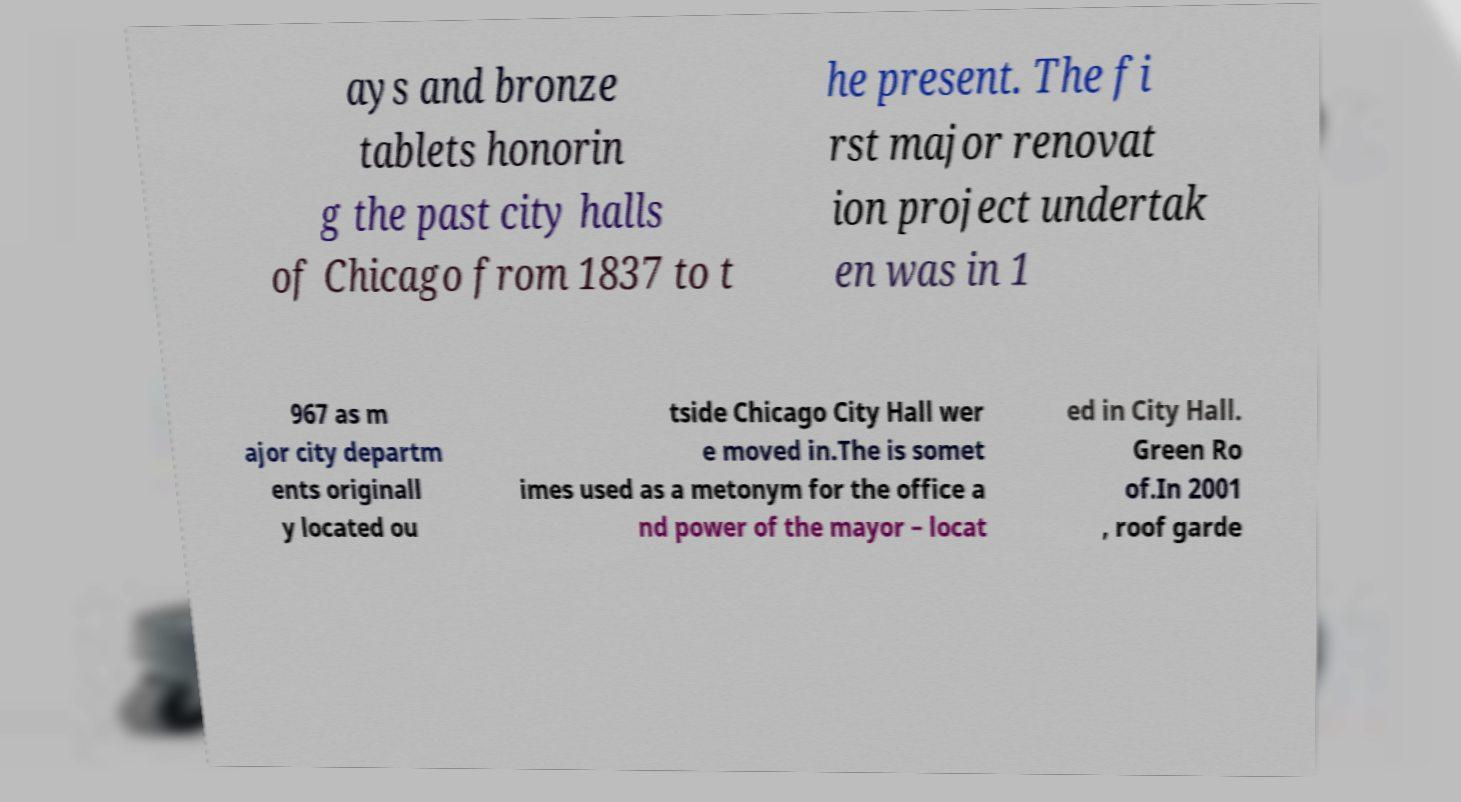What messages or text are displayed in this image? I need them in a readable, typed format. ays and bronze tablets honorin g the past city halls of Chicago from 1837 to t he present. The fi rst major renovat ion project undertak en was in 1 967 as m ajor city departm ents originall y located ou tside Chicago City Hall wer e moved in.The is somet imes used as a metonym for the office a nd power of the mayor – locat ed in City Hall. Green Ro of.In 2001 , roof garde 